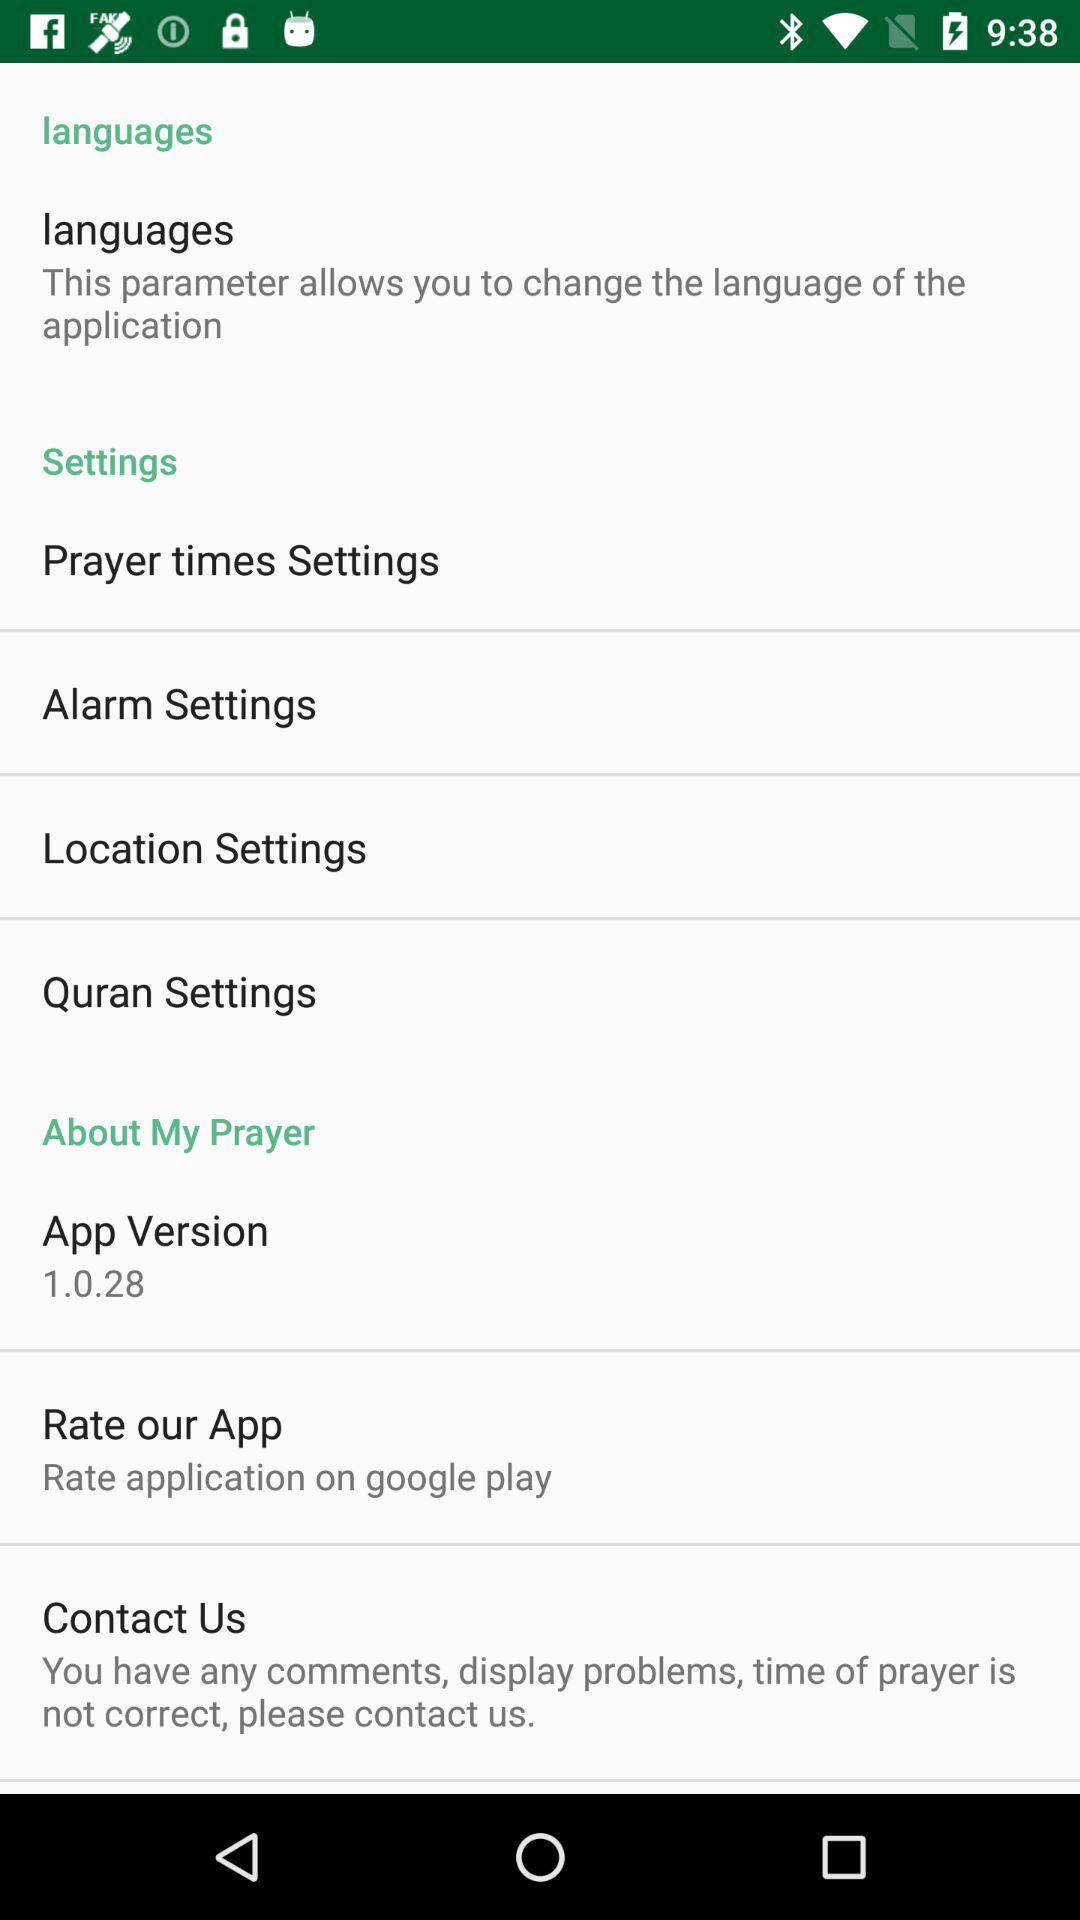What is the app version? The app version is 1.0.28. 